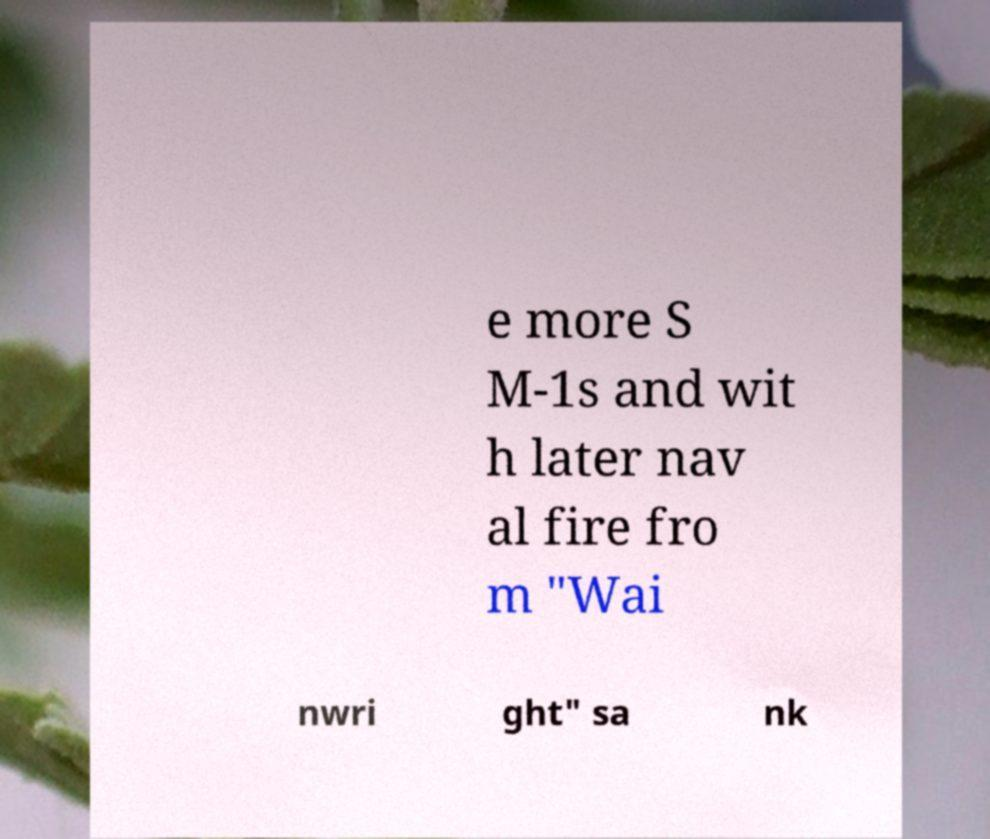Could you assist in decoding the text presented in this image and type it out clearly? e more S M-1s and wit h later nav al fire fro m "Wai nwri ght" sa nk 